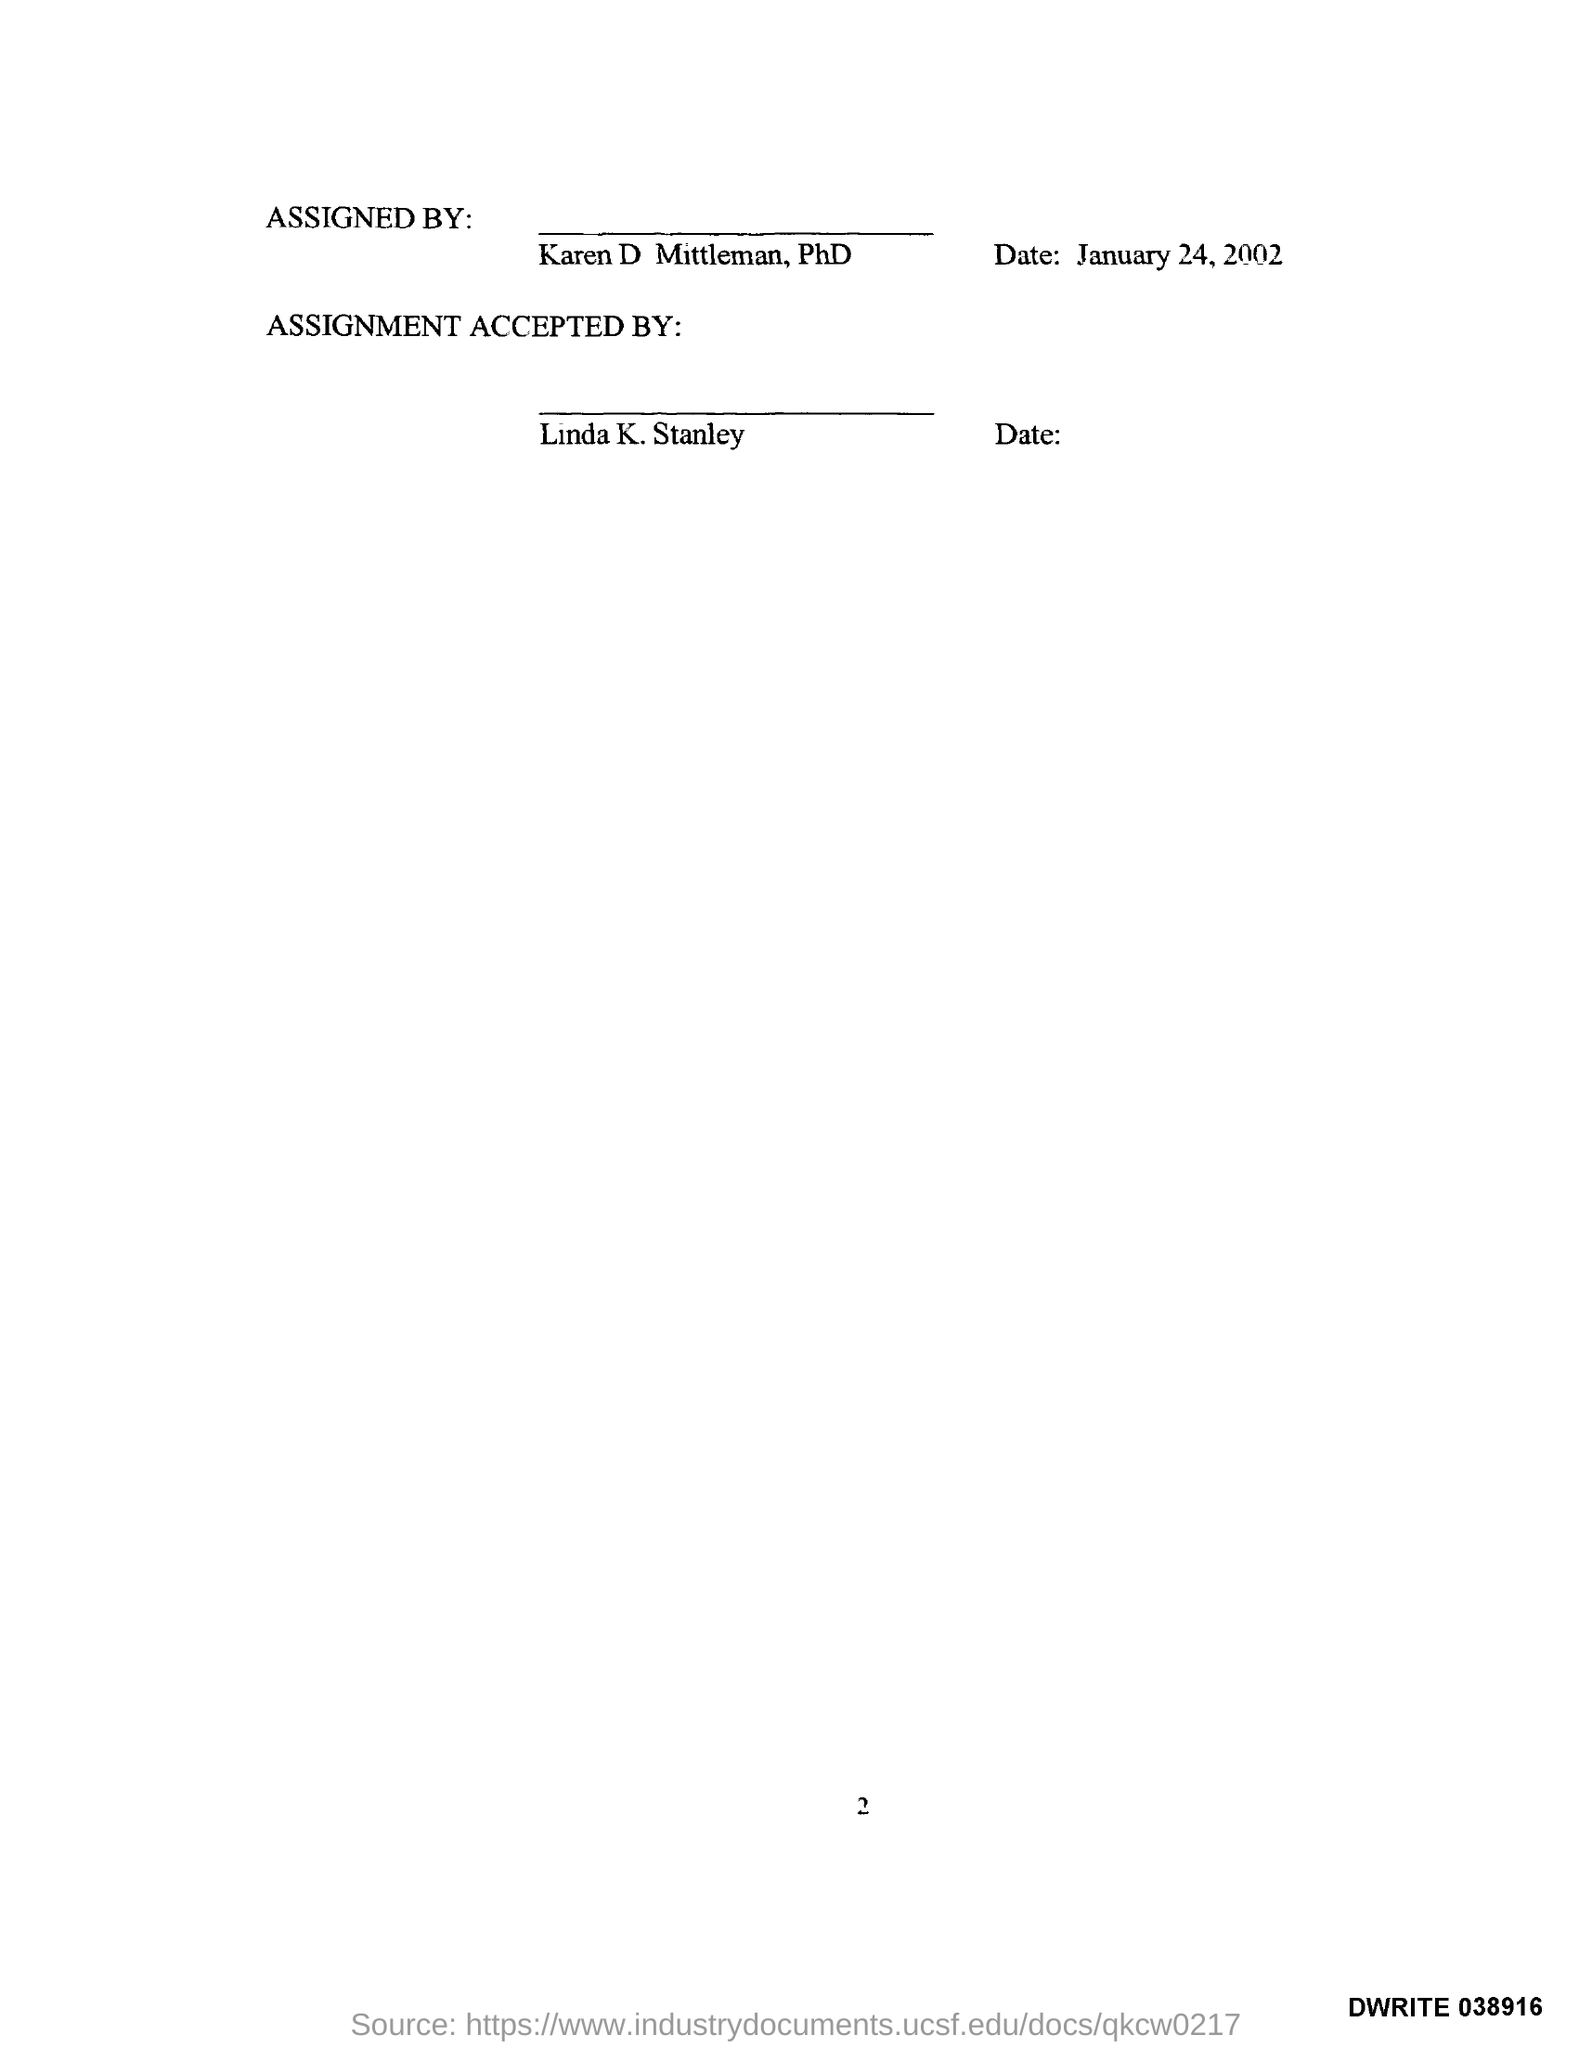Who has assigned the document?
Your response must be concise. Karen D. Mittleman, PhD. What is the date mentioned in this document?
Provide a short and direct response. JANUARY 24, 2002. Who has accepted the assignment?
Offer a terse response. Linda K. Stanley. What is the page no mentioned in this document?
Keep it short and to the point. 2. 